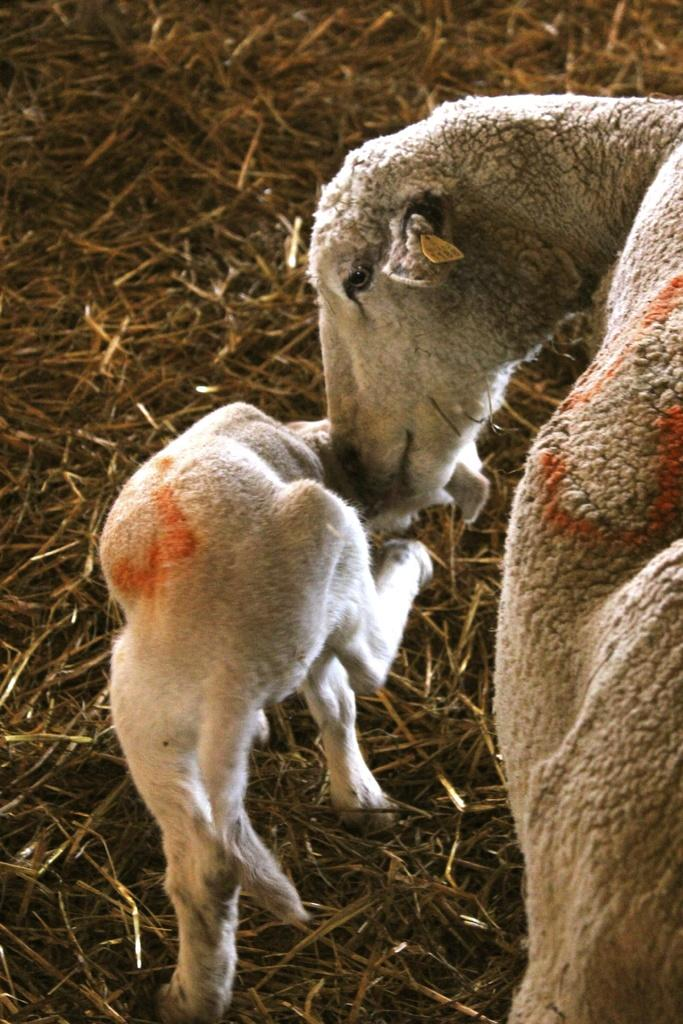What type of animals can be seen in the image? There is a sheep and a lamb in the image. What are the sheep and the lamb doing in the image? Both the sheep and the lamb are standing on the ground. What can be found on the ground in the image? Dry stems are lying on the ground in the image. What month is it in the image? The month cannot be determined from the image, as there is no information about the time of year. How many yards are there in the image? There is no reference to a yard or any measurement of distance in the image. 